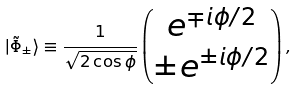<formula> <loc_0><loc_0><loc_500><loc_500>| \tilde { \Phi } _ { \pm } \rangle \equiv \frac { 1 } { \sqrt { 2 \cos \phi } } \left ( \begin{matrix} e ^ { \mp i \phi / 2 } \\ \pm e ^ { \pm i \phi / 2 } \end{matrix} \right ) ,</formula> 